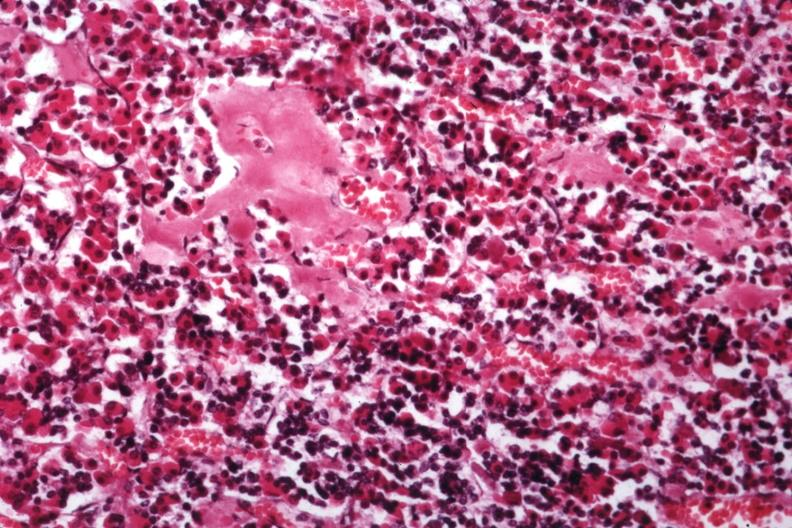what is present?
Answer the question using a single word or phrase. Amyloid angiopathy r. endocrine 